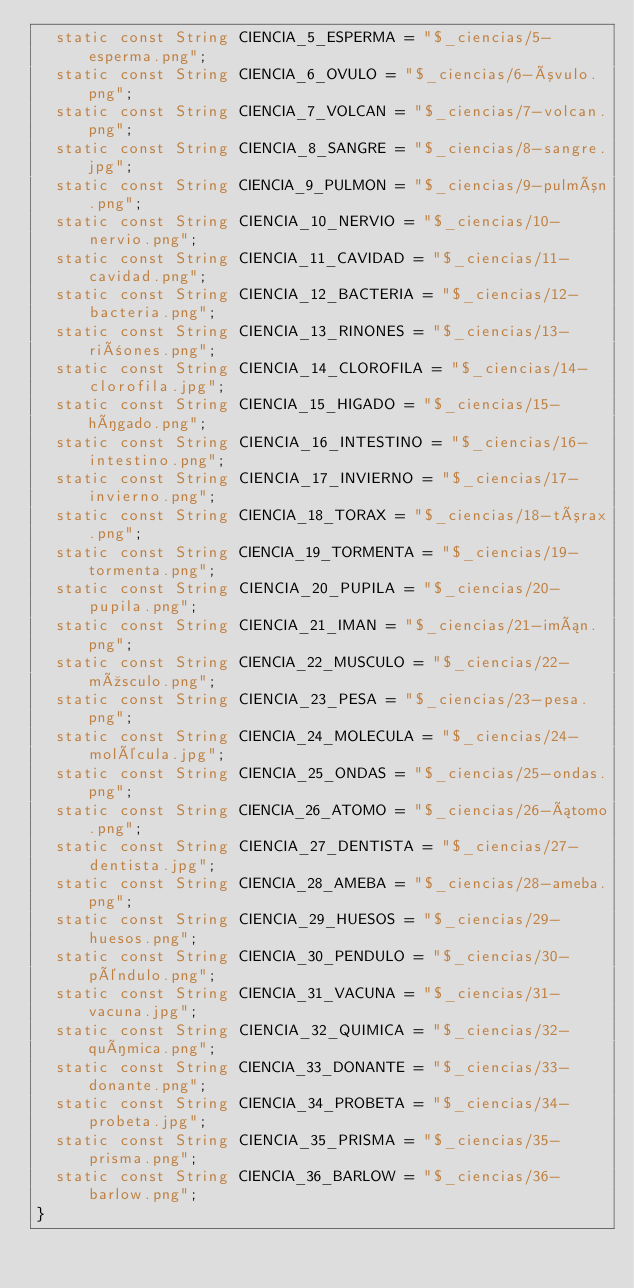Convert code to text. <code><loc_0><loc_0><loc_500><loc_500><_Dart_>  static const String CIENCIA_5_ESPERMA = "$_ciencias/5-esperma.png";
  static const String CIENCIA_6_OVULO = "$_ciencias/6-óvulo.png";
  static const String CIENCIA_7_VOLCAN = "$_ciencias/7-volcan.png";
  static const String CIENCIA_8_SANGRE = "$_ciencias/8-sangre.jpg";
  static const String CIENCIA_9_PULMON = "$_ciencias/9-pulmón.png";
  static const String CIENCIA_10_NERVIO = "$_ciencias/10-nervio.png";
  static const String CIENCIA_11_CAVIDAD = "$_ciencias/11-cavidad.png";
  static const String CIENCIA_12_BACTERIA = "$_ciencias/12-bacteria.png";
  static const String CIENCIA_13_RINONES = "$_ciencias/13-riñones.png";
  static const String CIENCIA_14_CLOROFILA = "$_ciencias/14-clorofila.jpg";
  static const String CIENCIA_15_HIGADO = "$_ciencias/15-hígado.png";
  static const String CIENCIA_16_INTESTINO = "$_ciencias/16-intestino.png";
  static const String CIENCIA_17_INVIERNO = "$_ciencias/17-invierno.png";
  static const String CIENCIA_18_TORAX = "$_ciencias/18-tórax.png";
  static const String CIENCIA_19_TORMENTA = "$_ciencias/19-tormenta.png";
  static const String CIENCIA_20_PUPILA = "$_ciencias/20-pupila.png";
  static const String CIENCIA_21_IMAN = "$_ciencias/21-imán.png";
  static const String CIENCIA_22_MUSCULO = "$_ciencias/22-músculo.png";
  static const String CIENCIA_23_PESA = "$_ciencias/23-pesa.png";
  static const String CIENCIA_24_MOLECULA = "$_ciencias/24-molécula.jpg";
  static const String CIENCIA_25_ONDAS = "$_ciencias/25-ondas.png";
  static const String CIENCIA_26_ATOMO = "$_ciencias/26-átomo.png";
  static const String CIENCIA_27_DENTISTA = "$_ciencias/27-dentista.jpg";
  static const String CIENCIA_28_AMEBA = "$_ciencias/28-ameba.png";
  static const String CIENCIA_29_HUESOS = "$_ciencias/29-huesos.png";
  static const String CIENCIA_30_PENDULO = "$_ciencias/30-péndulo.png";
  static const String CIENCIA_31_VACUNA = "$_ciencias/31-vacuna.jpg";
  static const String CIENCIA_32_QUIMICA = "$_ciencias/32-química.png";
  static const String CIENCIA_33_DONANTE = "$_ciencias/33-donante.png";
  static const String CIENCIA_34_PROBETA = "$_ciencias/34-probeta.jpg";
  static const String CIENCIA_35_PRISMA = "$_ciencias/35-prisma.png";
  static const String CIENCIA_36_BARLOW = "$_ciencias/36-barlow.png";
}
</code> 